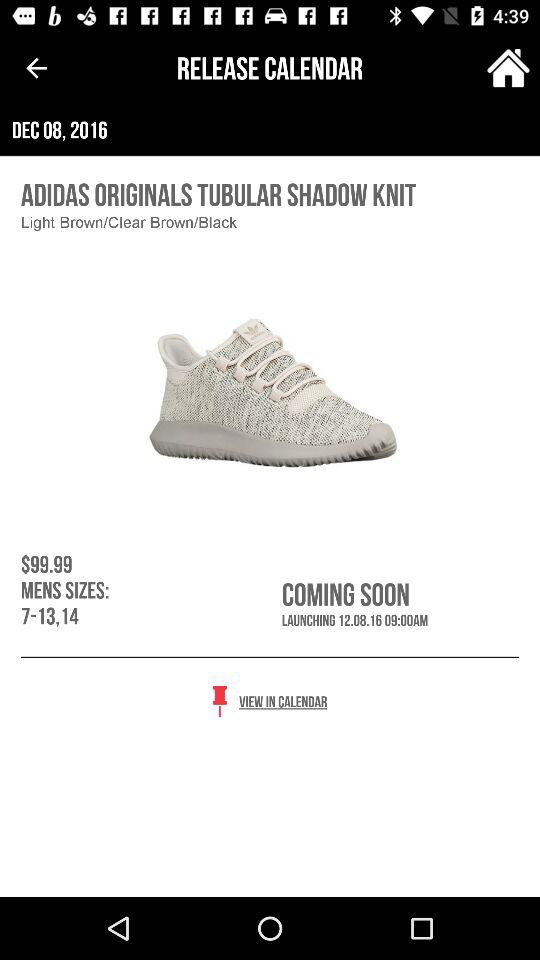What shoe sizes are available for men? The available shoe sizes are 7–13 and 14. 